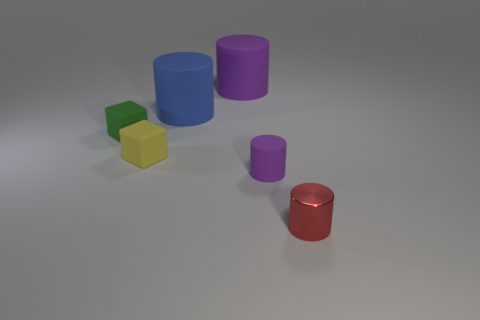Subtract all blue cylinders. How many cylinders are left? 3 Subtract all tiny purple cylinders. How many cylinders are left? 3 Add 4 tiny purple matte cylinders. How many objects exist? 10 Subtract 2 cubes. How many cubes are left? 0 Subtract all cyan cylinders. Subtract all green spheres. How many cylinders are left? 4 Subtract all brown blocks. How many purple cylinders are left? 2 Subtract all green rubber things. Subtract all large blue things. How many objects are left? 4 Add 1 tiny yellow rubber blocks. How many tiny yellow rubber blocks are left? 2 Add 5 tiny cubes. How many tiny cubes exist? 7 Subtract 0 gray balls. How many objects are left? 6 